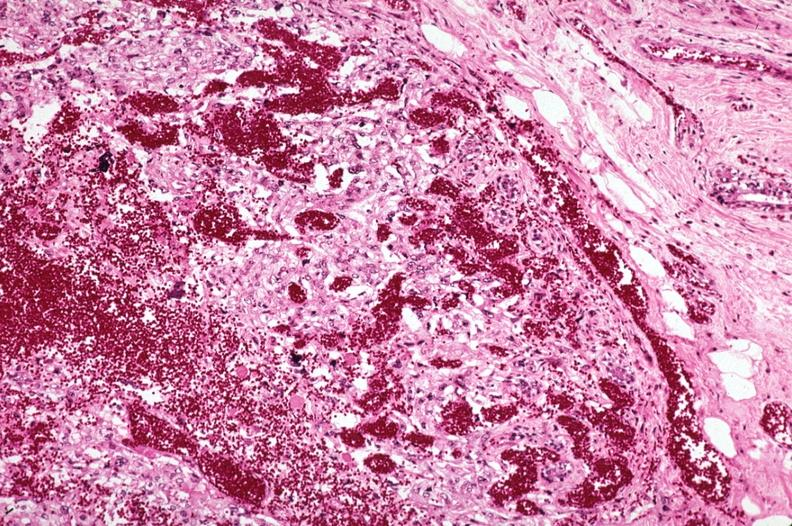what does this image show?
Answer the question using a single word or phrase. Metastatic choriocarcinoma with extensive vascularization 